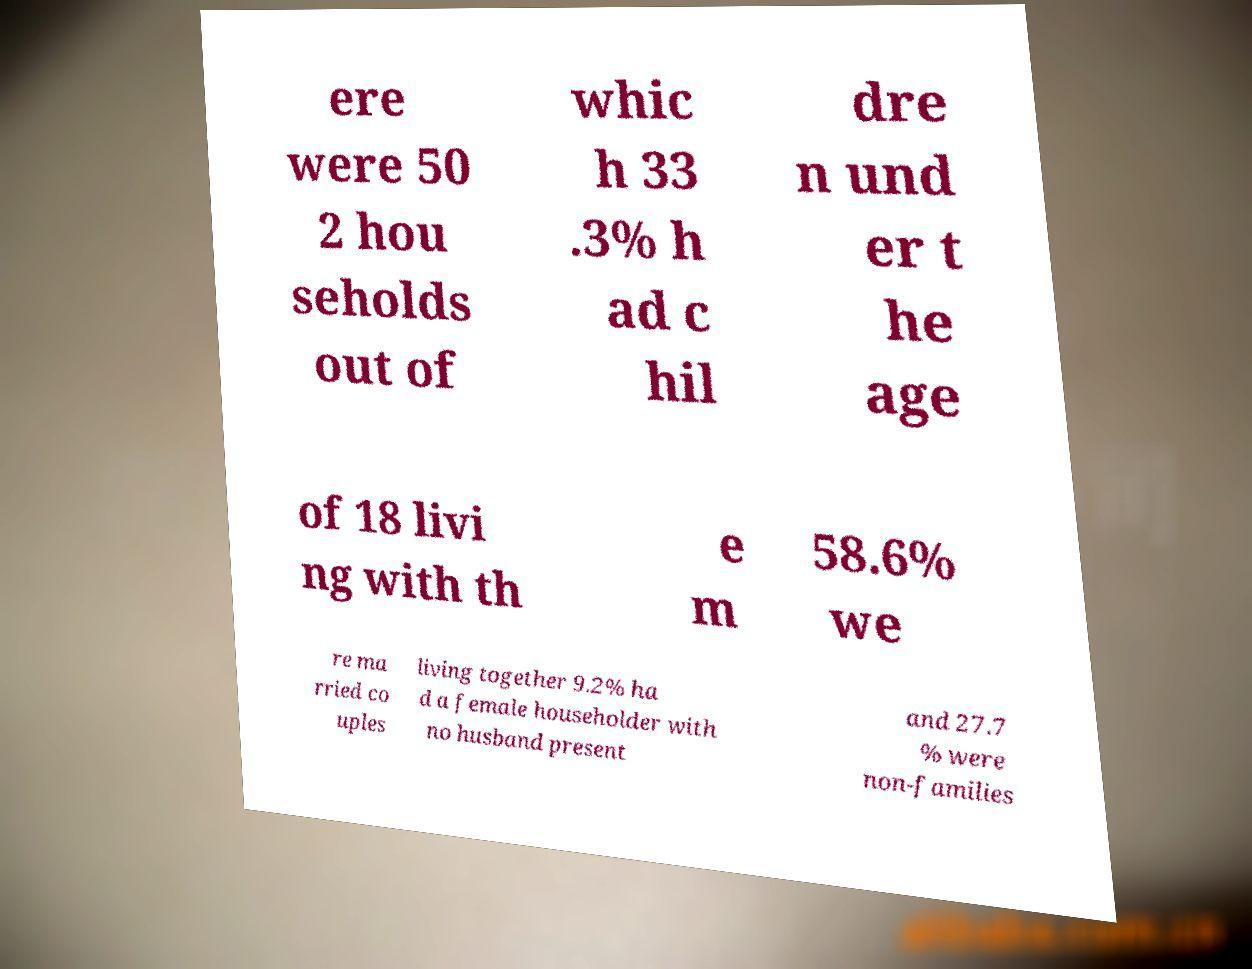Please identify and transcribe the text found in this image. ere were 50 2 hou seholds out of whic h 33 .3% h ad c hil dre n und er t he age of 18 livi ng with th e m 58.6% we re ma rried co uples living together 9.2% ha d a female householder with no husband present and 27.7 % were non-families 